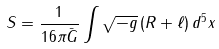Convert formula to latex. <formula><loc_0><loc_0><loc_500><loc_500>S = \frac { 1 } { 1 6 \pi \bar { G } } \int \sqrt { - g } \left ( R + \ell \right ) d ^ { 5 } x</formula> 